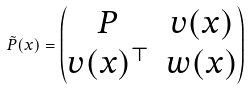<formula> <loc_0><loc_0><loc_500><loc_500>\tilde { P } ( x ) = \begin{pmatrix} P & v ( x ) \\ v ( x ) ^ { \top } & w ( x ) \\ \end{pmatrix}</formula> 